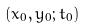<formula> <loc_0><loc_0><loc_500><loc_500>( x _ { 0 } , y _ { 0 } ; t _ { 0 } )</formula> 